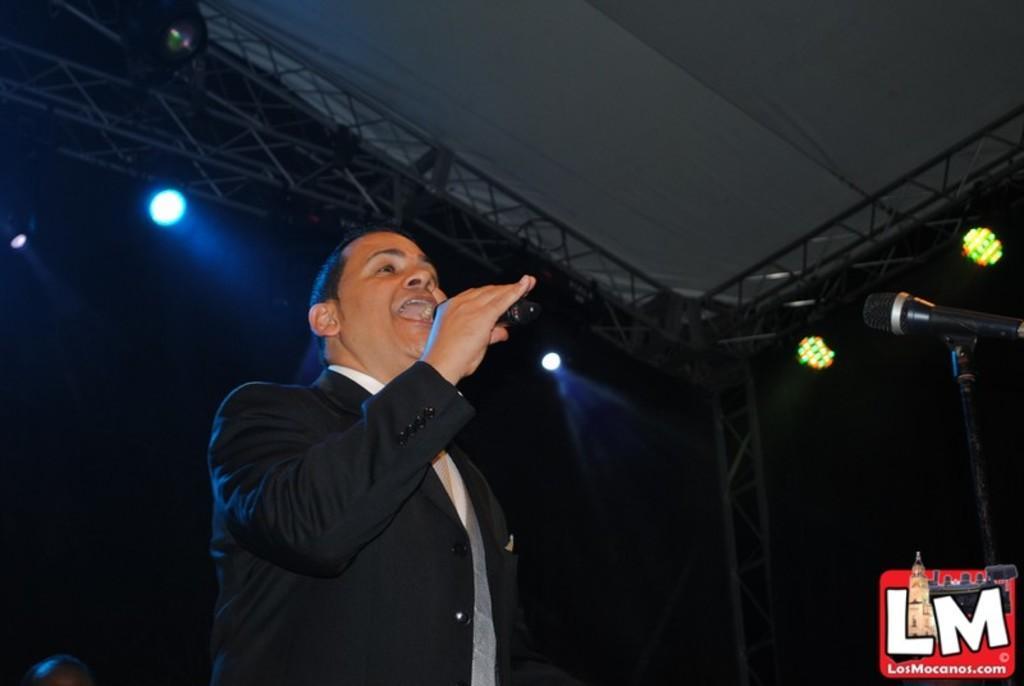Can you describe this image briefly? In this image I can see a person holding something and wearing black and white dress. In front I can see mic and stand. Top I can see a lights and iron stand. Background is in black color. 